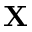Convert formula to latex. <formula><loc_0><loc_0><loc_500><loc_500>{ X }</formula> 